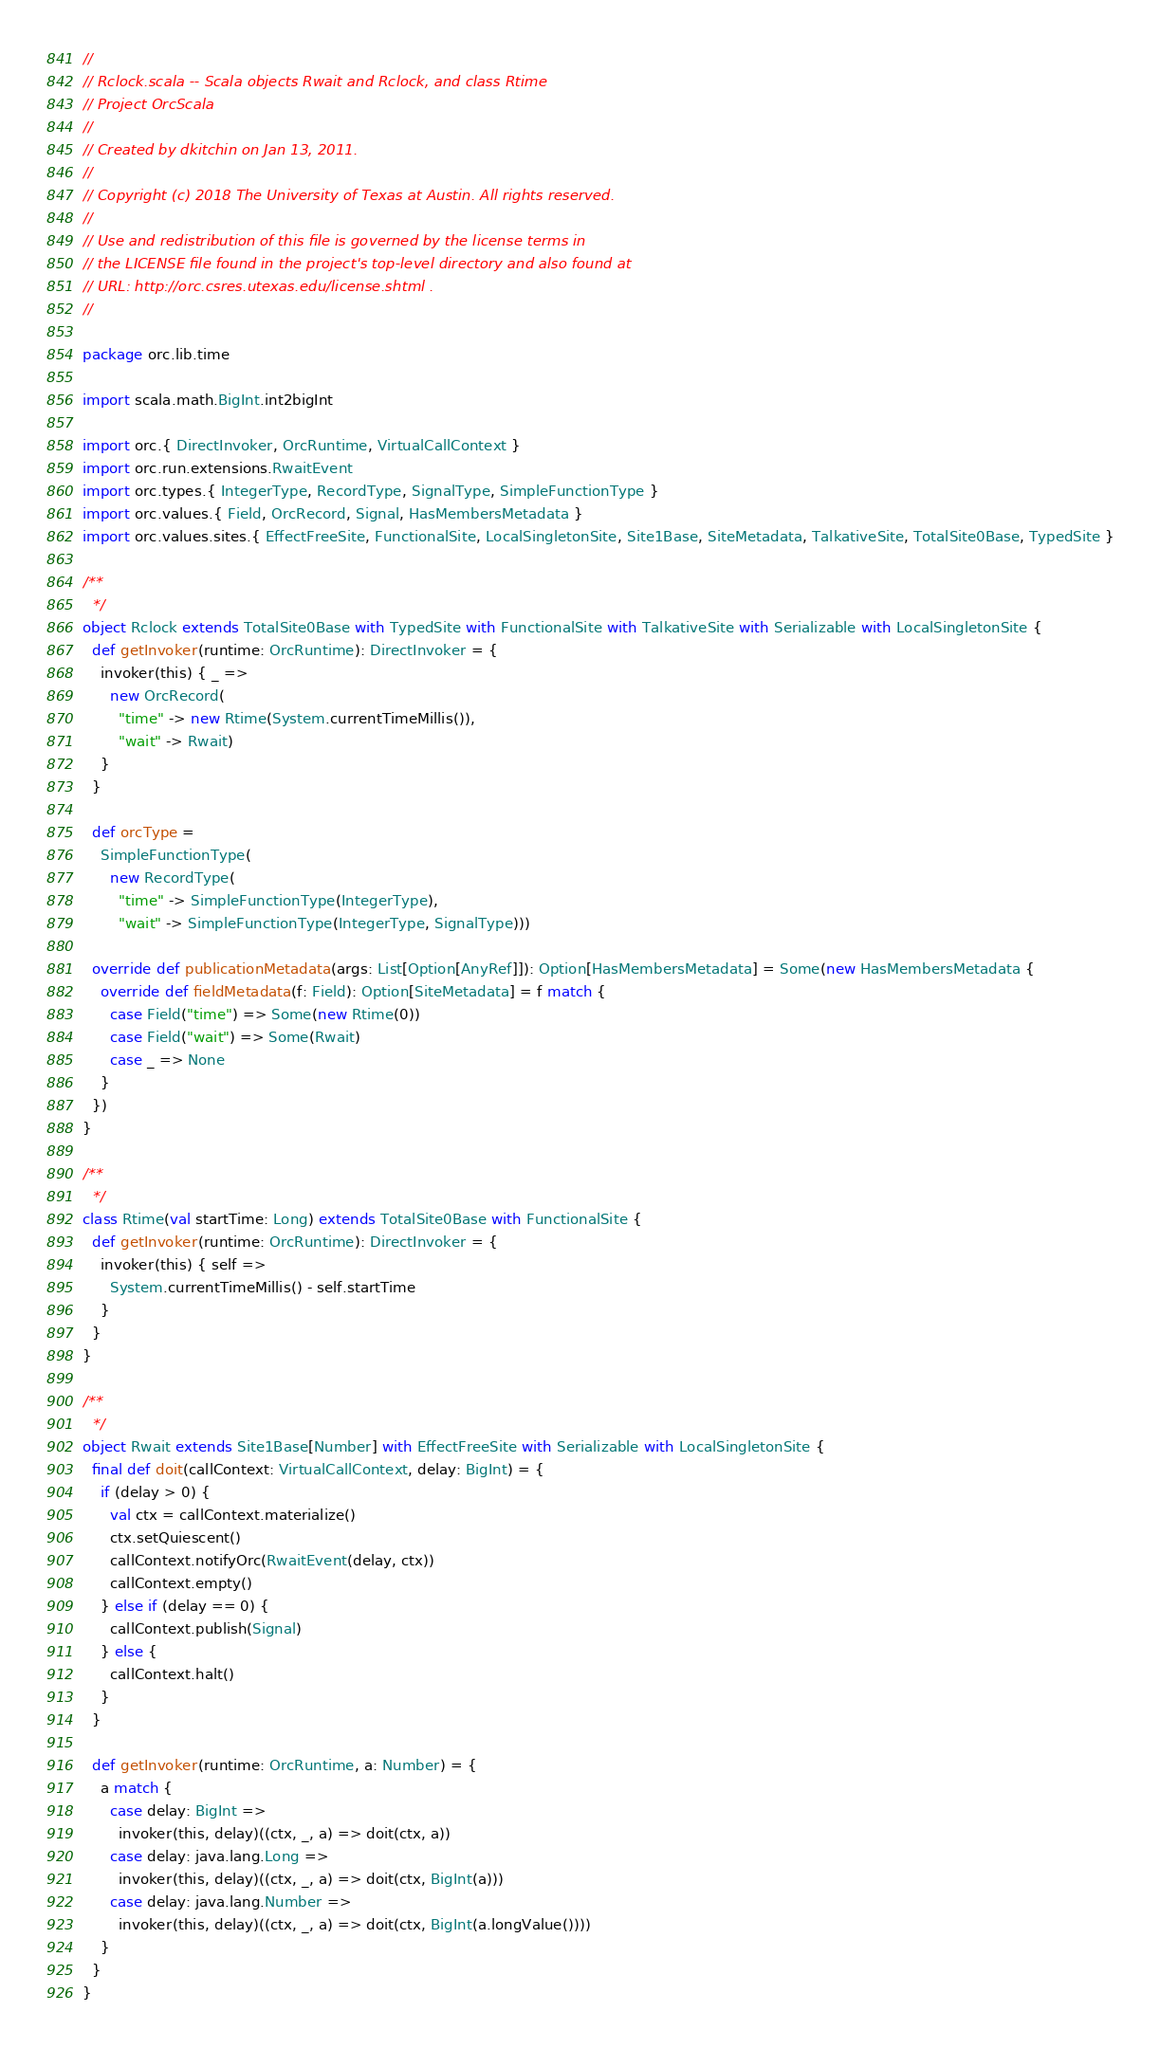<code> <loc_0><loc_0><loc_500><loc_500><_Scala_>//
// Rclock.scala -- Scala objects Rwait and Rclock, and class Rtime
// Project OrcScala
//
// Created by dkitchin on Jan 13, 2011.
//
// Copyright (c) 2018 The University of Texas at Austin. All rights reserved.
//
// Use and redistribution of this file is governed by the license terms in
// the LICENSE file found in the project's top-level directory and also found at
// URL: http://orc.csres.utexas.edu/license.shtml .
//

package orc.lib.time

import scala.math.BigInt.int2bigInt

import orc.{ DirectInvoker, OrcRuntime, VirtualCallContext }
import orc.run.extensions.RwaitEvent
import orc.types.{ IntegerType, RecordType, SignalType, SimpleFunctionType }
import orc.values.{ Field, OrcRecord, Signal, HasMembersMetadata }
import orc.values.sites.{ EffectFreeSite, FunctionalSite, LocalSingletonSite, Site1Base, SiteMetadata, TalkativeSite, TotalSite0Base, TypedSite }

/**
  */
object Rclock extends TotalSite0Base with TypedSite with FunctionalSite with TalkativeSite with Serializable with LocalSingletonSite {
  def getInvoker(runtime: OrcRuntime): DirectInvoker = {
    invoker(this) { _ =>
      new OrcRecord(
        "time" -> new Rtime(System.currentTimeMillis()),
        "wait" -> Rwait)
    }
  }

  def orcType =
    SimpleFunctionType(
      new RecordType(
        "time" -> SimpleFunctionType(IntegerType),
        "wait" -> SimpleFunctionType(IntegerType, SignalType)))

  override def publicationMetadata(args: List[Option[AnyRef]]): Option[HasMembersMetadata] = Some(new HasMembersMetadata {
    override def fieldMetadata(f: Field): Option[SiteMetadata] = f match {
      case Field("time") => Some(new Rtime(0))
      case Field("wait") => Some(Rwait)
      case _ => None
    }
  })
}

/**
  */
class Rtime(val startTime: Long) extends TotalSite0Base with FunctionalSite {
  def getInvoker(runtime: OrcRuntime): DirectInvoker = {
    invoker(this) { self =>
      System.currentTimeMillis() - self.startTime
    }
  }
}

/**
  */
object Rwait extends Site1Base[Number] with EffectFreeSite with Serializable with LocalSingletonSite {
  final def doit(callContext: VirtualCallContext, delay: BigInt) = {
    if (delay > 0) {
      val ctx = callContext.materialize()
      ctx.setQuiescent()
      callContext.notifyOrc(RwaitEvent(delay, ctx))
      callContext.empty()
    } else if (delay == 0) {
      callContext.publish(Signal)
    } else {
      callContext.halt()
    }
  }

  def getInvoker(runtime: OrcRuntime, a: Number) = {
    a match {
      case delay: BigInt =>
        invoker(this, delay)((ctx, _, a) => doit(ctx, a))
      case delay: java.lang.Long =>
        invoker(this, delay)((ctx, _, a) => doit(ctx, BigInt(a)))
      case delay: java.lang.Number =>
        invoker(this, delay)((ctx, _, a) => doit(ctx, BigInt(a.longValue())))
    }
  }
}
</code> 